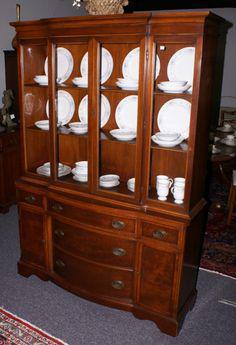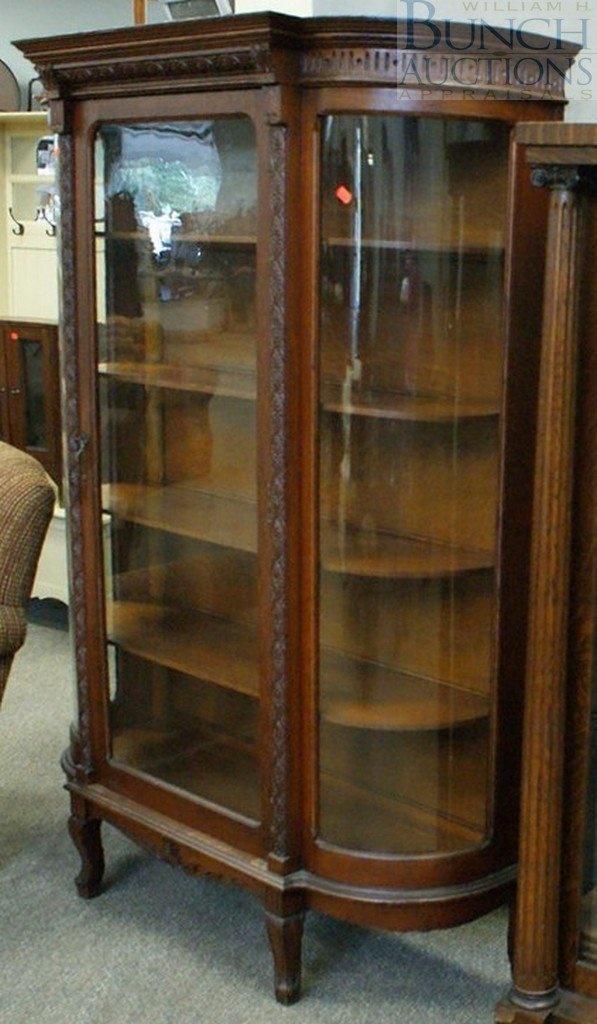The first image is the image on the left, the second image is the image on the right. For the images displayed, is the sentence "One china cabinet has three stacked drawers on the bottom and three upper shelves filled with dishes." factually correct? Answer yes or no. Yes. 